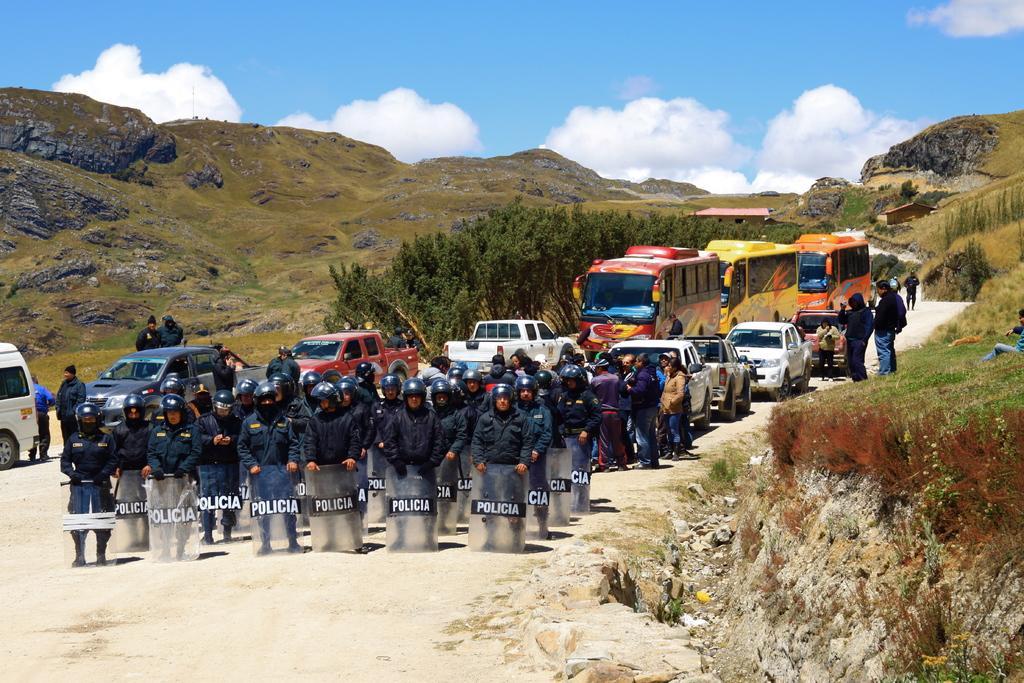Describe this image in one or two sentences. In this image, we can see a group of people. Few are holding shields and wearing helmets. There are so many vehicles are parked on the road. On the right side and background we can see grass and plants. Here we can see trees, mountains and house. Top of the image, there is a cloudy sky. 